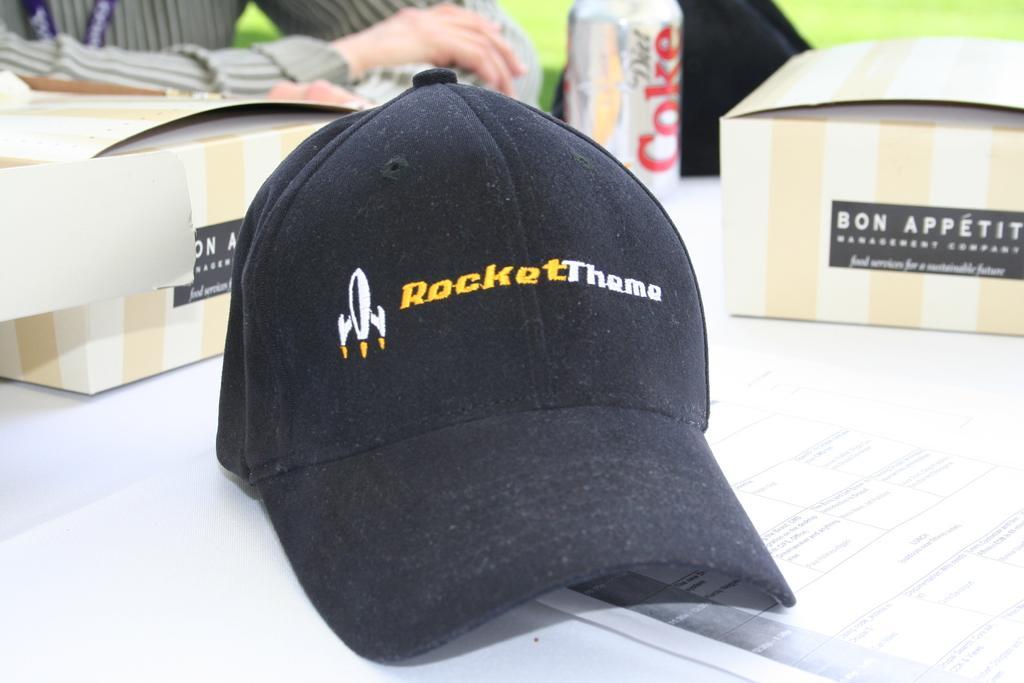In one or two sentences, can you explain what this image depicts? In the picture I can see a black color cap in the middle of the image and it is on the table. I can see a paper, two stock boxes and a coke tin are kept on the table. I can see the hands of a person on the top left side. 